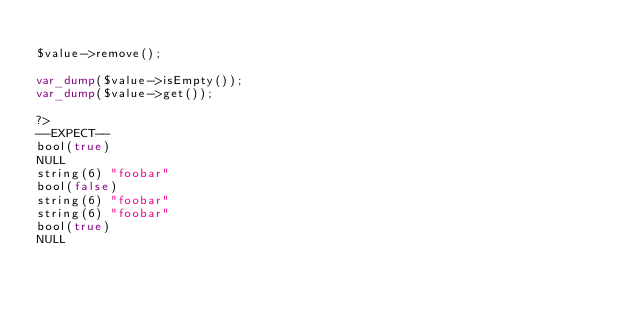<code> <loc_0><loc_0><loc_500><loc_500><_PHP_>
$value->remove();

var_dump($value->isEmpty());
var_dump($value->get());

?>
--EXPECT--
bool(true)
NULL
string(6) "foobar"
bool(false)
string(6) "foobar"
string(6) "foobar"
bool(true)
NULL</code> 